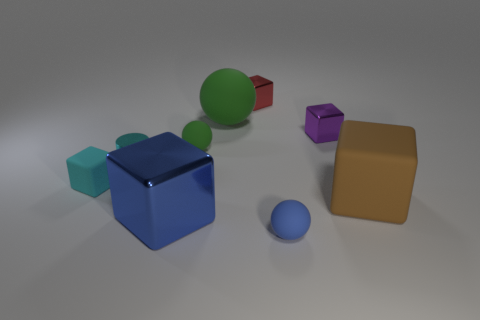Subtract all purple blocks. How many blocks are left? 4 Subtract all red spheres. Subtract all purple cylinders. How many spheres are left? 3 Subtract all cubes. How many objects are left? 4 Subtract all tiny blue shiny cylinders. Subtract all metallic blocks. How many objects are left? 6 Add 3 small green rubber objects. How many small green rubber objects are left? 4 Add 2 small cyan matte blocks. How many small cyan matte blocks exist? 3 Subtract 0 purple cylinders. How many objects are left? 9 